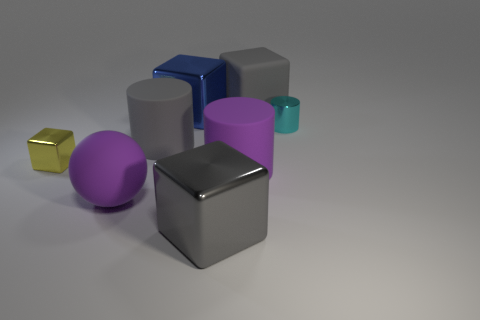Subtract all yellow cubes. How many cubes are left? 3 Add 2 purple rubber objects. How many objects exist? 10 Subtract all cyan cubes. Subtract all green balls. How many cubes are left? 4 Subtract all cylinders. How many objects are left? 5 Subtract 0 yellow balls. How many objects are left? 8 Subtract all tiny cyan cylinders. Subtract all small yellow cubes. How many objects are left? 6 Add 2 tiny yellow metallic blocks. How many tiny yellow metallic blocks are left? 3 Add 3 large gray cylinders. How many large gray cylinders exist? 4 